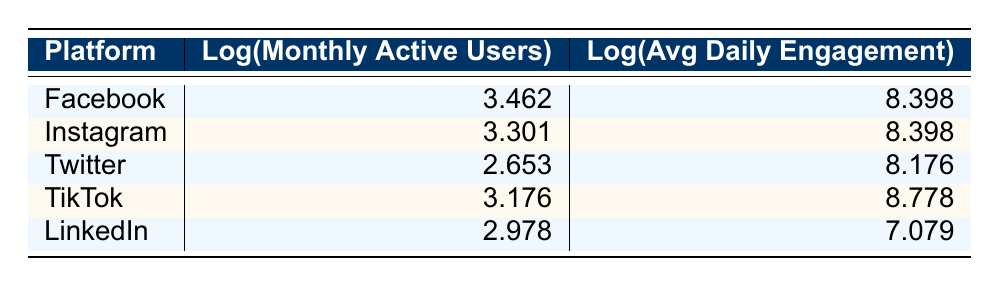What is the log value of monthly active users for Facebook? The table lists Facebook's log monthly active users as 3.462 in the corresponding cell.
Answer: 3.462 Which platform has the highest log value for average daily engagement? Examining the table, TikTok has the log value of average daily engagement as 8.778, which is the highest compared to the other platforms.
Answer: TikTok What is the difference in log monthly active users between Instagram and LinkedIn? Instagram's log monthly active users is 3.301 and LinkedIn's is 2.978. The difference is 3.301 - 2.978 = 0.323.
Answer: 0.323 Is TikTok's log average daily engagement greater than that of Twitter? The log average daily engagement for TikTok is 8.778, while for Twitter it's 8.176. Since 8.778 is greater than 8.176, the answer is yes.
Answer: Yes What platform has the second highest log monthly active users? The log monthly active users are ranked as follows: Facebook (3.462), Instagram (3.301), TikTok (3.176), LinkedIn (2.978), and Twitter (2.653). Instagram has the second highest value after Facebook.
Answer: Instagram What is the average of the log monthly active users for all platforms? To find the average, sum the log monthly active users: 3.462 + 3.301 + 2.653 + 3.176 + 2.978 = 15.570. There are 5 platforms, so the average is 15.570 / 5 = 3.114.
Answer: 3.114 Which platform has the lowest log average daily engagement? Reviewing the table, LinkedIn has the lowest log average daily engagement at 7.079, lower than all other platforms listed.
Answer: LinkedIn What is the sum of the log values for average daily engagement across all platforms? The log values for average daily engagement are 8.398 (Facebook), 8.398 (Instagram), 8.176 (Twitter), 8.778 (TikTok), and 7.079 (LinkedIn). Summing these values gives 8.398 + 8.398 + 8.176 + 8.778 + 7.079 = 40.829.
Answer: 40.829 